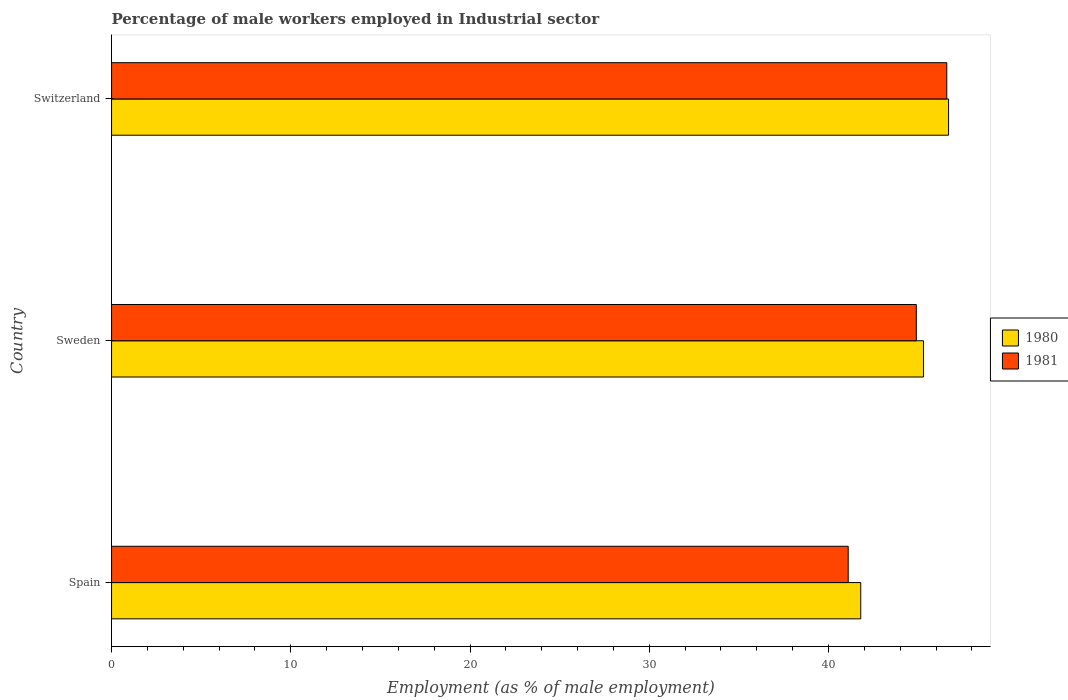How many different coloured bars are there?
Offer a very short reply. 2. How many bars are there on the 3rd tick from the top?
Your answer should be compact. 2. What is the percentage of male workers employed in Industrial sector in 1981 in Switzerland?
Give a very brief answer. 46.6. Across all countries, what is the maximum percentage of male workers employed in Industrial sector in 1981?
Keep it short and to the point. 46.6. Across all countries, what is the minimum percentage of male workers employed in Industrial sector in 1980?
Keep it short and to the point. 41.8. In which country was the percentage of male workers employed in Industrial sector in 1981 maximum?
Offer a terse response. Switzerland. What is the total percentage of male workers employed in Industrial sector in 1980 in the graph?
Your answer should be very brief. 133.8. What is the difference between the percentage of male workers employed in Industrial sector in 1980 in Sweden and that in Switzerland?
Give a very brief answer. -1.4. What is the difference between the percentage of male workers employed in Industrial sector in 1981 in Switzerland and the percentage of male workers employed in Industrial sector in 1980 in Sweden?
Your response must be concise. 1.3. What is the average percentage of male workers employed in Industrial sector in 1980 per country?
Your answer should be compact. 44.6. What is the difference between the percentage of male workers employed in Industrial sector in 1981 and percentage of male workers employed in Industrial sector in 1980 in Sweden?
Offer a terse response. -0.4. What is the ratio of the percentage of male workers employed in Industrial sector in 1980 in Spain to that in Switzerland?
Ensure brevity in your answer.  0.9. Is the percentage of male workers employed in Industrial sector in 1981 in Spain less than that in Switzerland?
Make the answer very short. Yes. Is the difference between the percentage of male workers employed in Industrial sector in 1981 in Spain and Sweden greater than the difference between the percentage of male workers employed in Industrial sector in 1980 in Spain and Sweden?
Make the answer very short. No. What is the difference between the highest and the second highest percentage of male workers employed in Industrial sector in 1980?
Your answer should be very brief. 1.4. What is the difference between the highest and the lowest percentage of male workers employed in Industrial sector in 1980?
Provide a succinct answer. 4.9. In how many countries, is the percentage of male workers employed in Industrial sector in 1981 greater than the average percentage of male workers employed in Industrial sector in 1981 taken over all countries?
Your response must be concise. 2. What does the 1st bar from the top in Sweden represents?
Provide a short and direct response. 1981. How many bars are there?
Make the answer very short. 6. How many countries are there in the graph?
Ensure brevity in your answer.  3. What is the difference between two consecutive major ticks on the X-axis?
Your answer should be compact. 10. Are the values on the major ticks of X-axis written in scientific E-notation?
Make the answer very short. No. Does the graph contain grids?
Make the answer very short. No. How many legend labels are there?
Keep it short and to the point. 2. What is the title of the graph?
Make the answer very short. Percentage of male workers employed in Industrial sector. Does "1995" appear as one of the legend labels in the graph?
Keep it short and to the point. No. What is the label or title of the X-axis?
Make the answer very short. Employment (as % of male employment). What is the label or title of the Y-axis?
Keep it short and to the point. Country. What is the Employment (as % of male employment) in 1980 in Spain?
Offer a very short reply. 41.8. What is the Employment (as % of male employment) of 1981 in Spain?
Give a very brief answer. 41.1. What is the Employment (as % of male employment) in 1980 in Sweden?
Offer a very short reply. 45.3. What is the Employment (as % of male employment) of 1981 in Sweden?
Provide a short and direct response. 44.9. What is the Employment (as % of male employment) of 1980 in Switzerland?
Your response must be concise. 46.7. What is the Employment (as % of male employment) of 1981 in Switzerland?
Provide a short and direct response. 46.6. Across all countries, what is the maximum Employment (as % of male employment) of 1980?
Give a very brief answer. 46.7. Across all countries, what is the maximum Employment (as % of male employment) in 1981?
Keep it short and to the point. 46.6. Across all countries, what is the minimum Employment (as % of male employment) in 1980?
Your response must be concise. 41.8. Across all countries, what is the minimum Employment (as % of male employment) in 1981?
Make the answer very short. 41.1. What is the total Employment (as % of male employment) in 1980 in the graph?
Give a very brief answer. 133.8. What is the total Employment (as % of male employment) in 1981 in the graph?
Keep it short and to the point. 132.6. What is the difference between the Employment (as % of male employment) in 1980 in Spain and that in Switzerland?
Your answer should be compact. -4.9. What is the difference between the Employment (as % of male employment) in 1981 in Spain and that in Switzerland?
Offer a very short reply. -5.5. What is the difference between the Employment (as % of male employment) in 1980 in Sweden and that in Switzerland?
Your answer should be very brief. -1.4. What is the average Employment (as % of male employment) in 1980 per country?
Offer a very short reply. 44.6. What is the average Employment (as % of male employment) of 1981 per country?
Your answer should be very brief. 44.2. What is the ratio of the Employment (as % of male employment) of 1980 in Spain to that in Sweden?
Your answer should be compact. 0.92. What is the ratio of the Employment (as % of male employment) in 1981 in Spain to that in Sweden?
Your answer should be compact. 0.92. What is the ratio of the Employment (as % of male employment) in 1980 in Spain to that in Switzerland?
Your response must be concise. 0.9. What is the ratio of the Employment (as % of male employment) in 1981 in Spain to that in Switzerland?
Make the answer very short. 0.88. What is the ratio of the Employment (as % of male employment) of 1981 in Sweden to that in Switzerland?
Make the answer very short. 0.96. What is the difference between the highest and the second highest Employment (as % of male employment) in 1980?
Your answer should be very brief. 1.4. 